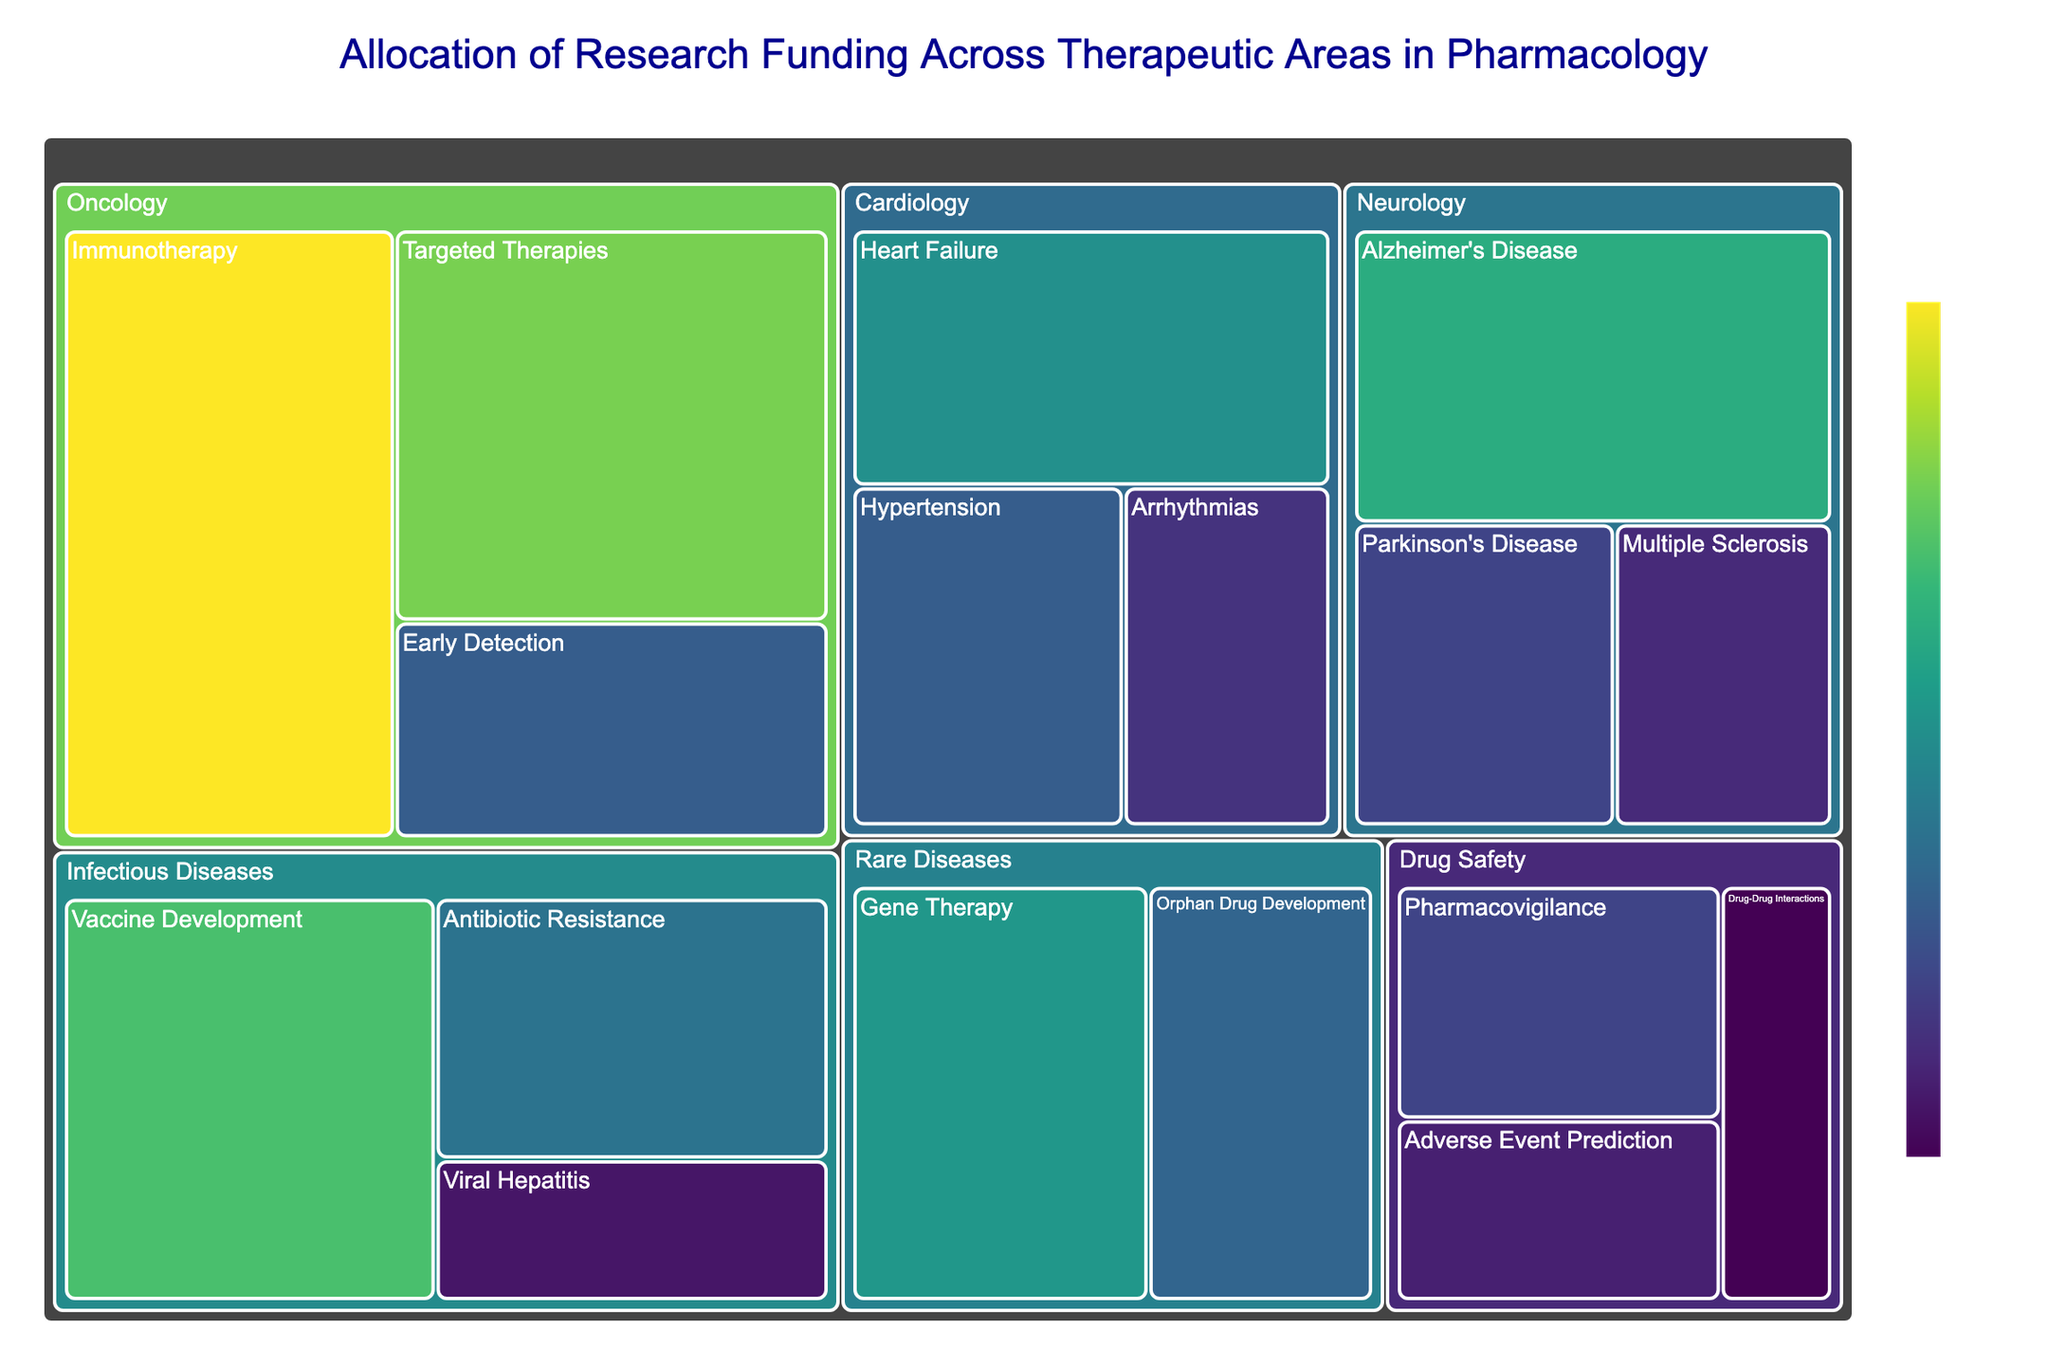Which therapeutic area receives the highest total funding? The Treemap shows different therapeutic areas with varying sizes of tiles representing their funding. The area with the largest tile is Oncology.
Answer: Oncology Which subcategory in Cardiology receives the most funding? By looking into the Cardiology section of the Treemap, the subcategory with the largest tile is Heart Failure.
Answer: Heart Failure What is the total combined funding for Neurology? To find the total funding for Neurology, sum the funding for all its subcategories: Alzheimer's Disease ($320M), Parkinson's Disease ($180M), and Multiple Sclerosis ($150M). The total is \(320 + 180 + 150 = 650\).
Answer: 650 million USD Which subcategory within Oncology has the least funding? Look at the Oncology category and identify the smallest tile among its subcategories. The subcategory with the smallest tile is Early Detection.
Answer: Early Detection How much more funding does Vaccine Development receive compared to Antibiotic Resistance? Vaccine Development has $350M in funding, and Antibiotic Resistance has $240M in funding. The difference is \(350 - 240 = 110\).
Answer: 110 million USD Which category receives the least total funding? Compare the total funding across all categories by summing their respective subcategories. The category with the smallest sum is Drug Safety with \(180 + 140 + 110 = 430\).
Answer: Drug Safety What is the average funding for subcategories within Rare Diseases? Calculate the average by summing the funding for Gene Therapy ($290M) and Orphan Drug Development ($220M) and dividing by the number of subcategories: \((290 + 220) / 2 = 255\).
Answer: 255 million USD Rank the categories from highest to lowest total funding. Sum the funding for each category: Oncology ($1040M), Neurology ($650M), Cardiology ($650M), Infectious Diseases ($720M), Rare Diseases ($510M), Drug Safety ($430M). The order from highest to lowest is: Oncology, Infectious Diseases, Neurology, Cardiology, Rare Diseases, Drug Safety.
Answer: Oncology, Infectious Diseases, Neurology, Cardiology, Rare Diseases, Drug Safety Which subcategory receives exactly $280 million in funding? Look for the subcategory tile with a funding label of $280M. It is Heart Failure in the Cardiology category.
Answer: Heart Failure Are there more subcategories in Neurology or Cardiology, and by how many? Count the subcategories in the Neurology and Cardiology sections. Neurology has 3, and Cardiology has 3. The difference is \(3 - 3 = 0\).
Answer: The number of subcategories is the same by 0 